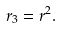<formula> <loc_0><loc_0><loc_500><loc_500>r _ { 3 } = r ^ { 2 } .</formula> 